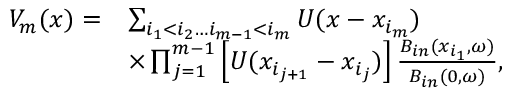Convert formula to latex. <formula><loc_0><loc_0><loc_500><loc_500>\begin{array} { r l } { V _ { m } ( x ) = } & { \sum _ { i _ { 1 } < i _ { 2 } \dots i _ { m - 1 } < i _ { m } } U ( x - x _ { i _ { m } } ) } \\ & { \times \prod _ { j = 1 } ^ { m - 1 } \left [ U ( x _ { i _ { j + 1 } } - x _ { i _ { j } } ) \right ] \frac { B _ { i n } ( x _ { i _ { 1 } } , \omega ) } { B _ { i n } ( 0 , \omega ) } , } \end{array}</formula> 